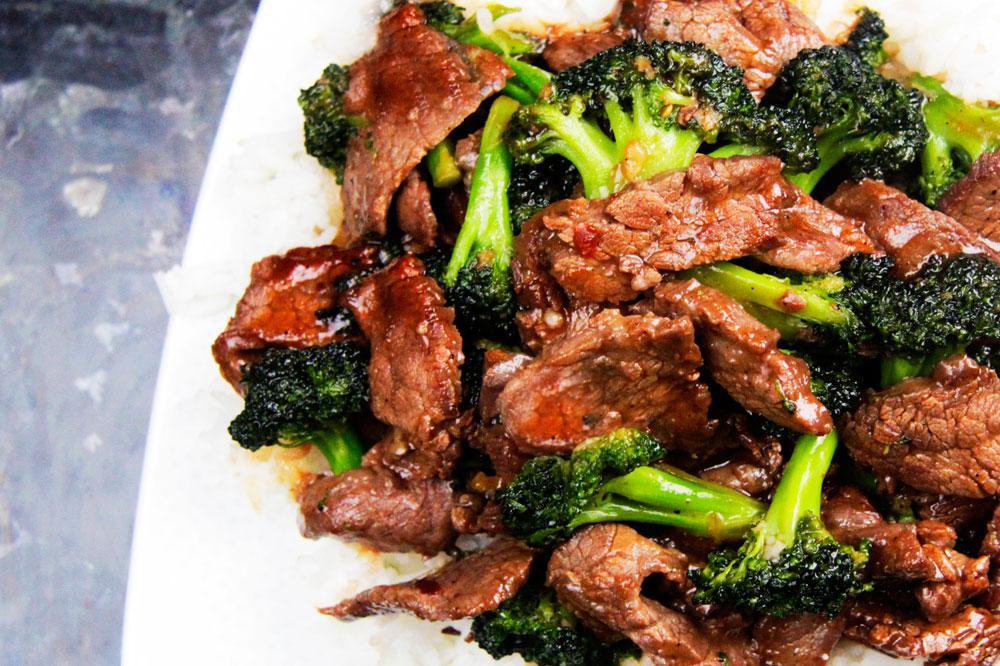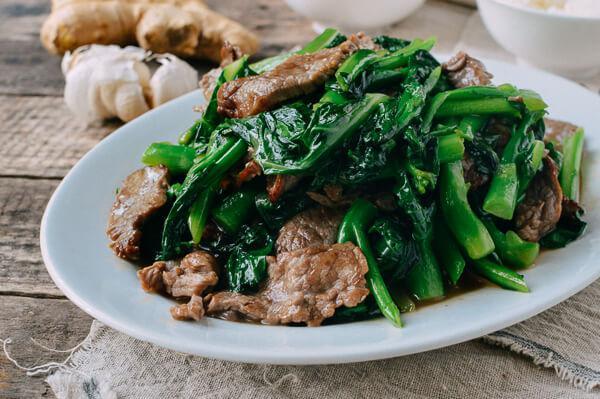The first image is the image on the left, the second image is the image on the right. Assess this claim about the two images: "The food in the image on the right is being served in a white dish.". Correct or not? Answer yes or no. Yes. The first image is the image on the left, the second image is the image on the right. Evaluate the accuracy of this statement regarding the images: "Right image shows a white plate containing an entree that includes white rice and broccoli.". Is it true? Answer yes or no. No. 